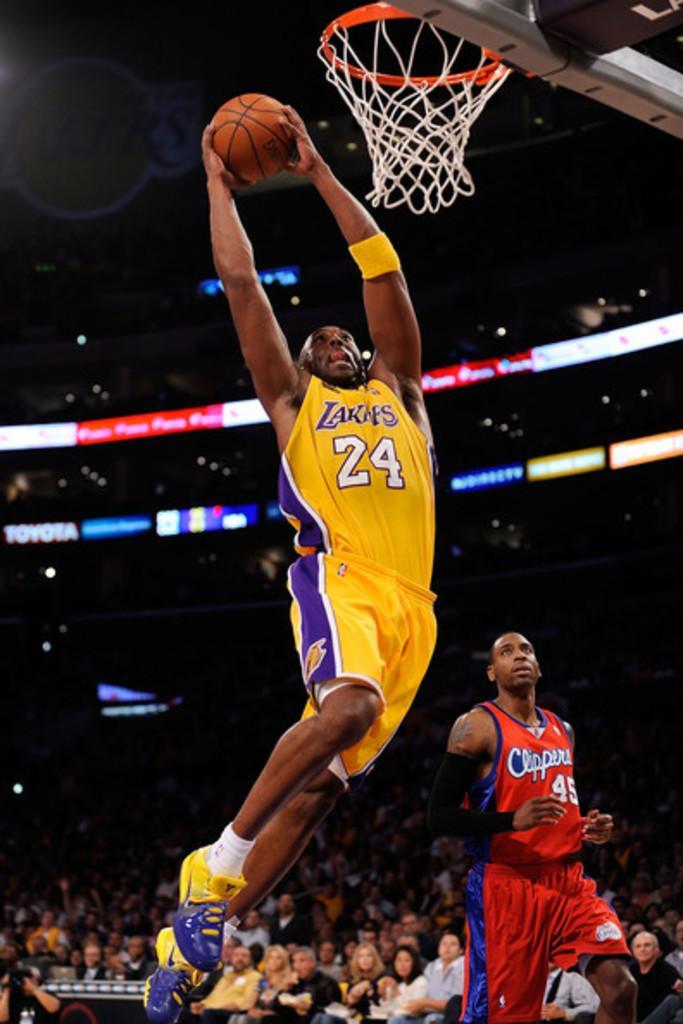Please provide a concise description of this image. In the foreground of this image, there is a man holding a ball is in the air. Behind him, there is another man. At the top, there is a basket. In the background, there are people sitting and few banners and the lights. 